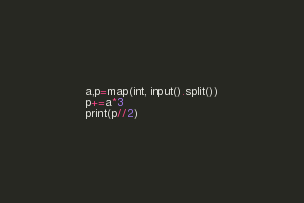<code> <loc_0><loc_0><loc_500><loc_500><_Python_>a,p=map(int, input().split())
p+=a*3
print(p//2)</code> 